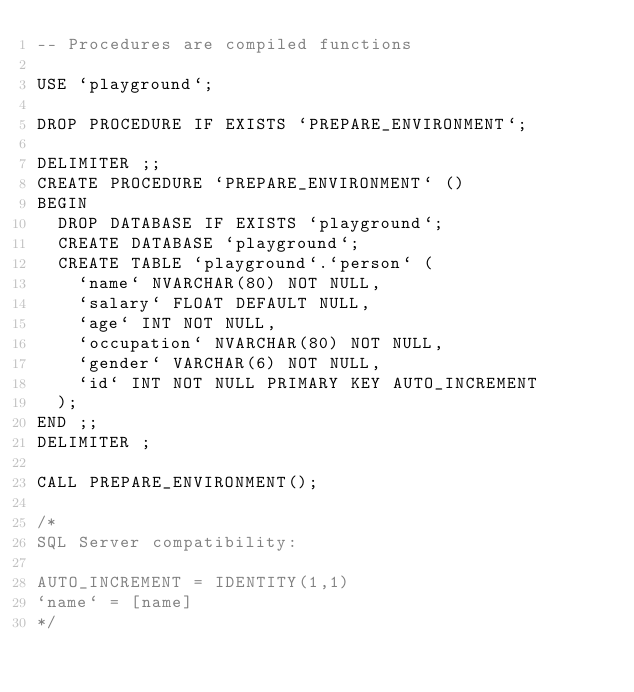<code> <loc_0><loc_0><loc_500><loc_500><_SQL_>-- Procedures are compiled functions

USE `playground`;

DROP PROCEDURE IF EXISTS `PREPARE_ENVIRONMENT`;

DELIMITER ;;
CREATE PROCEDURE `PREPARE_ENVIRONMENT` ()
BEGIN
	DROP DATABASE IF EXISTS `playground`;
	CREATE DATABASE `playground`;
	CREATE TABLE `playground`.`person` (
		`name` NVARCHAR(80) NOT NULL,
		`salary` FLOAT DEFAULT NULL,
		`age` INT NOT NULL,
		`occupation` NVARCHAR(80) NOT NULL,
		`gender` VARCHAR(6) NOT NULL,
		`id` INT NOT NULL PRIMARY KEY AUTO_INCREMENT
	);
END ;;
DELIMITER ;

CALL PREPARE_ENVIRONMENT();

/*
SQL Server compatibility:

AUTO_INCREMENT = IDENTITY(1,1)
`name` = [name]
*/
</code> 